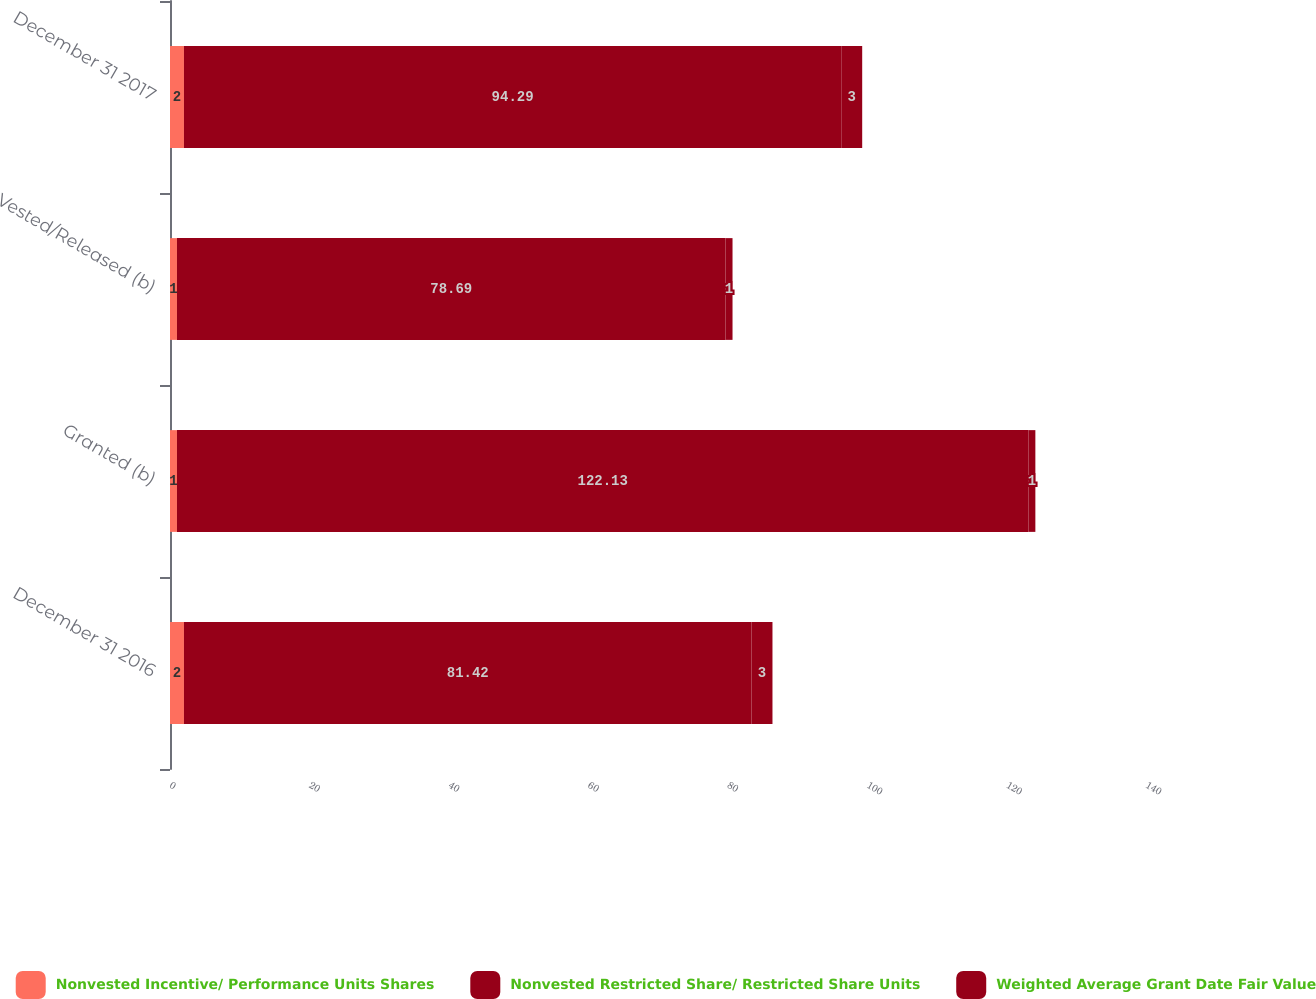Convert chart. <chart><loc_0><loc_0><loc_500><loc_500><stacked_bar_chart><ecel><fcel>December 31 2016<fcel>Granted (b)<fcel>Vested/Released (b)<fcel>December 31 2017<nl><fcel>Nonvested Incentive/ Performance Units Shares<fcel>2<fcel>1<fcel>1<fcel>2<nl><fcel>Nonvested Restricted Share/ Restricted Share Units<fcel>81.42<fcel>122.13<fcel>78.69<fcel>94.29<nl><fcel>Weighted Average Grant Date Fair Value<fcel>3<fcel>1<fcel>1<fcel>3<nl></chart> 